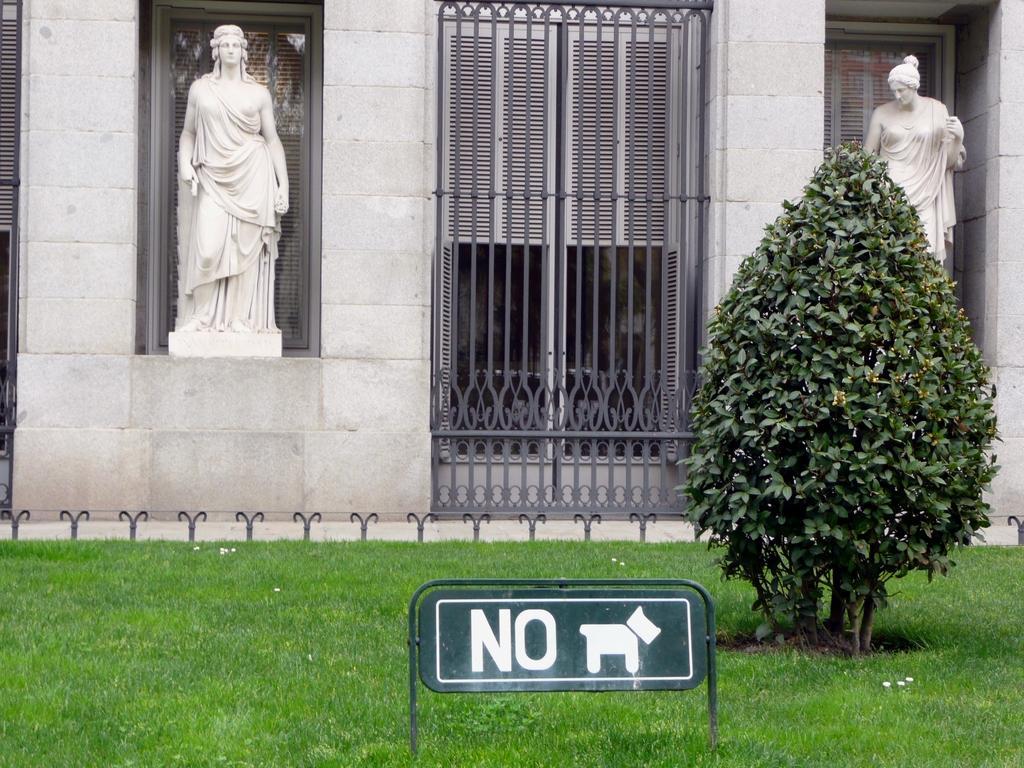Please provide a concise description of this image. In this image I see 2 statues which are of white in color and I see the wall and I see the grills over here and I see the grass, plants and a board on which there is a board which says "NO". 